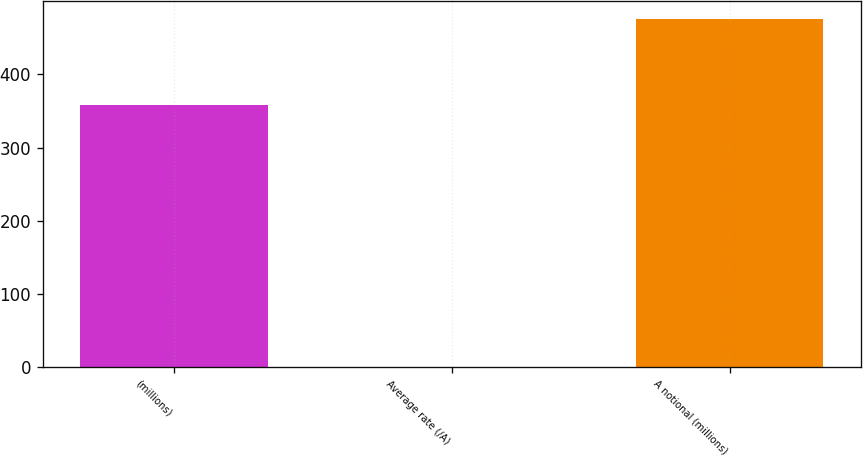Convert chart. <chart><loc_0><loc_0><loc_500><loc_500><bar_chart><fcel>(millions)<fcel>Average rate (/A)<fcel>A notional (millions)<nl><fcel>358<fcel>0.75<fcel>476<nl></chart> 